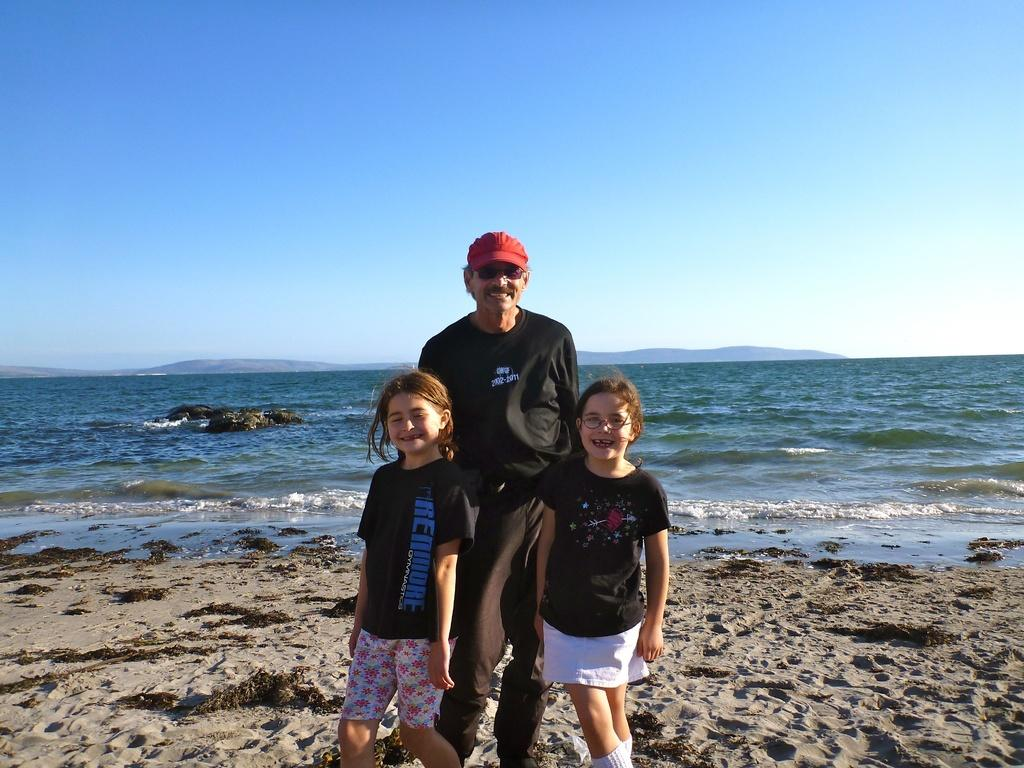What is the main subject in the foreground of the image? There is a man standing in the foreground of the image. How many girls are present in the image? There are two girls in the image. What can be seen in the background of the image? Water and the sky are visible in the background of the image. What type of terrain is at the bottom of the image? There is sand at the bottom of the image. What type of trouble can be seen in the cemetery in the image? There is no cemetery present in the image, and therefore no trouble can be observed. 